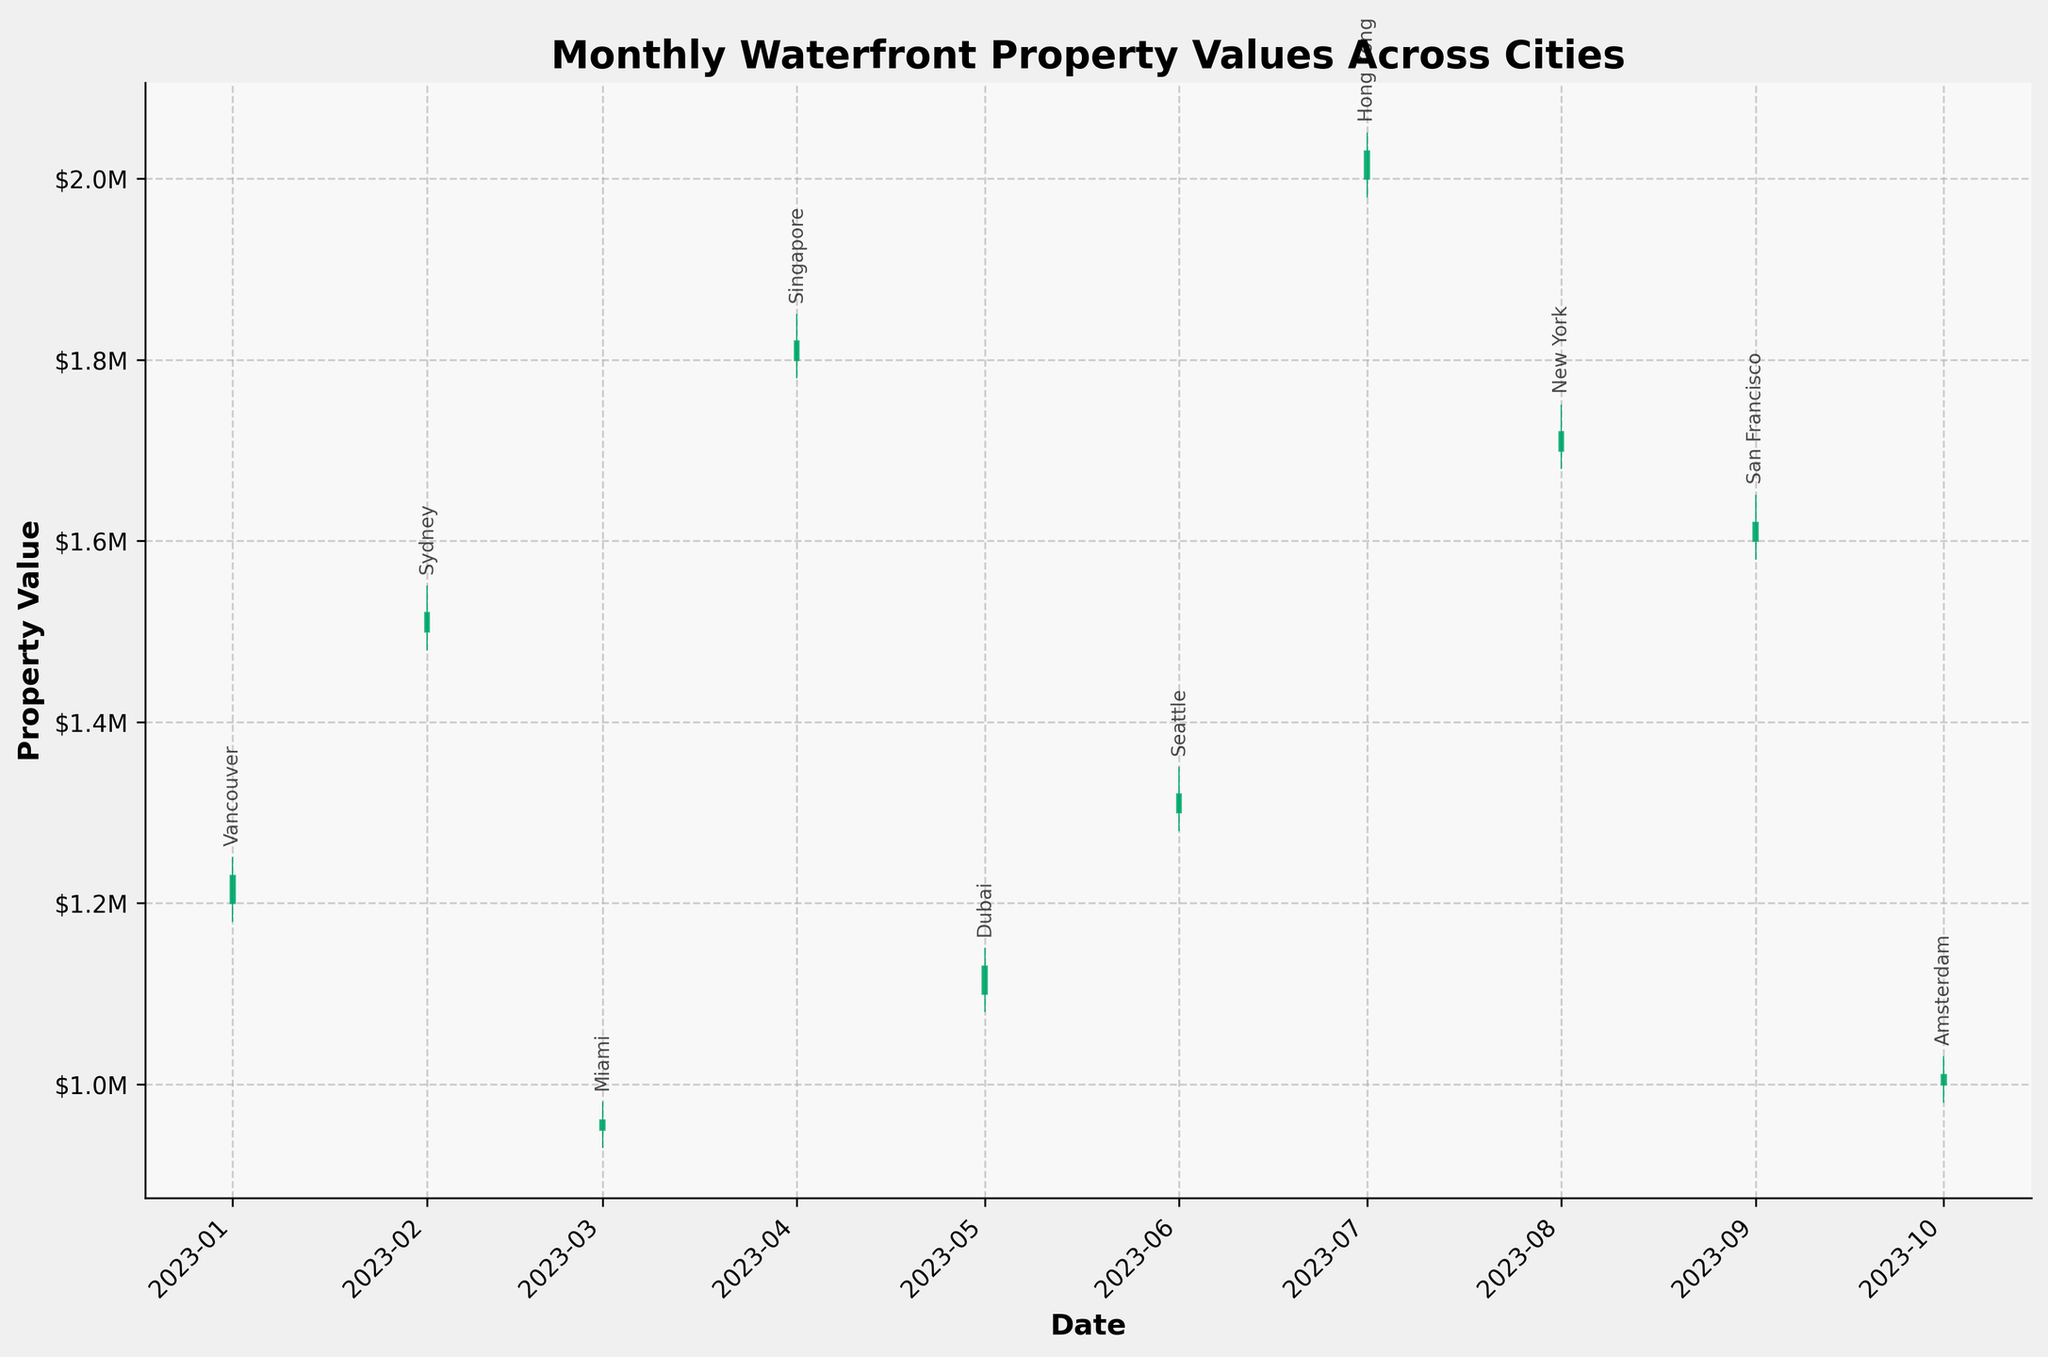what is the title of the figure? The title is usually displayed at the top of the chart, providing a summary of what the chart represents. In this chart, the title is “Monthly Waterfront Property Values Across Cities”.
Answer: Monthly Waterfront Property Values Across Cities How many cities are represented in the chart? Each OHLC bar represents data for one city. By counting these bars, you can determine how many cities are included.
Answer: 10 When did Hong Kong have its highest value, and what was the value? Find the bar corresponding to Hong Kong and look for the maximum value on that bar, which represents the high price point.
Answer: 2023-07, $2,050,000 Which city had the lowest close value and what was that value? To find this, compare the closing values of all the cities and identify the one with the lowest closing point.
Answer: Miami, $960,000 What was the approximate property value range for Seattle in June 2023? Refer to the OHLC bar for Seattle. The range is determined by the difference between the high and low values.
Answer: Between $1,280,000 and $1,350,000 Which city had the highest increase in monthly property value from open to close? For each city, calculate the difference between the close and open values. Compare these differences to find the one with the highest positive change.
Answer: Hong Kong Compare the property values in New York and San Francisco. Which month had a higher closing value and by how much? Locate the OHLC bars for New York and San Francisco and compare their closing values. Subtract to find the difference.
Answer: New York, $172,000 What is the average high value across all cities? To calculate this, sum all the high values and divide by the number of cities.
Answer: $1,565,000 In which months did more than one city reach a high property value of over $1,700,000? Identify months where any city's high value exceeded $1,700,000 and count them.
Answer: July, August, September Which city's property value fluctuated the least in its month, and what was the fluctuation range? Examine the OHLC bars to find the smallest range between high and low values.
Answer: Miami, $50,000 